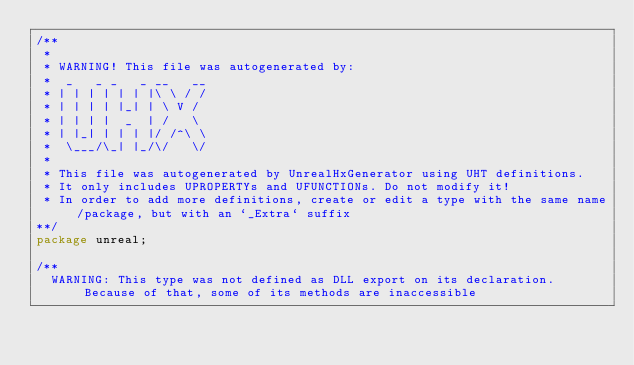<code> <loc_0><loc_0><loc_500><loc_500><_Haxe_>/**
 * 
 * WARNING! This file was autogenerated by: 
 *  _   _ _   _ __   __ 
 * | | | | | | |\ \ / / 
 * | | | | |_| | \ V /  
 * | | | |  _  | /   \  
 * | |_| | | | |/ /^\ \ 
 *  \___/\_| |_/\/   \/ 
 * 
 * This file was autogenerated by UnrealHxGenerator using UHT definitions.
 * It only includes UPROPERTYs and UFUNCTIONs. Do not modify it!
 * In order to add more definitions, create or edit a type with the same name/package, but with an `_Extra` suffix
**/
package unreal;

/**
  WARNING: This type was not defined as DLL export on its declaration. Because of that, some of its methods are inaccessible
  
  </code> 